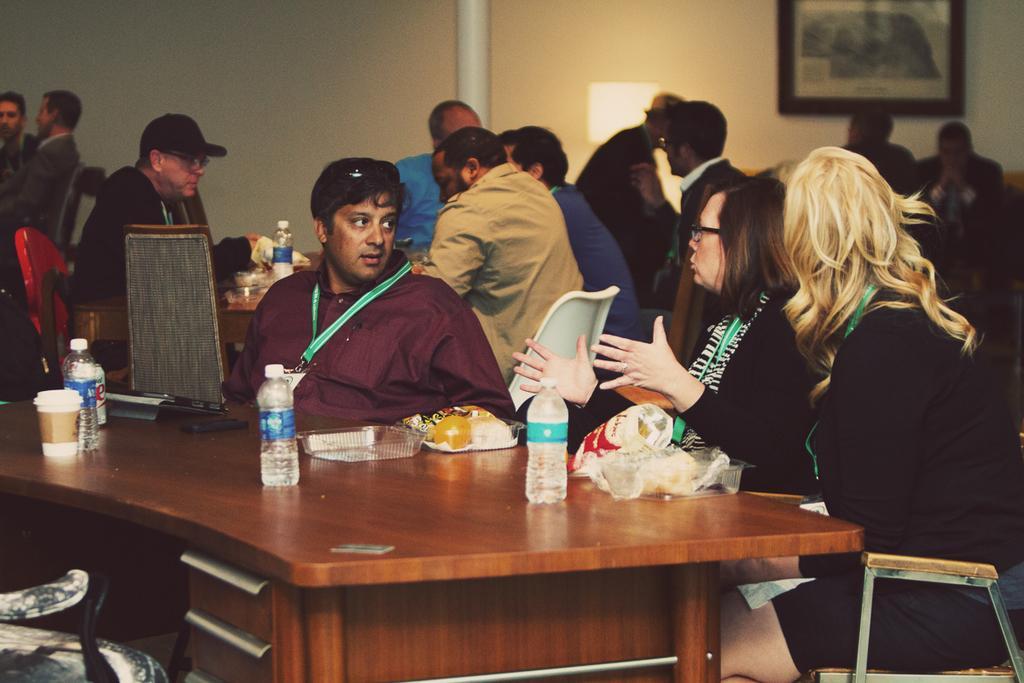Please provide a concise description of this image. In the image we can see there are people who are sitting on chair and on table we can see there is laptop, chips packet and coffee cup. 